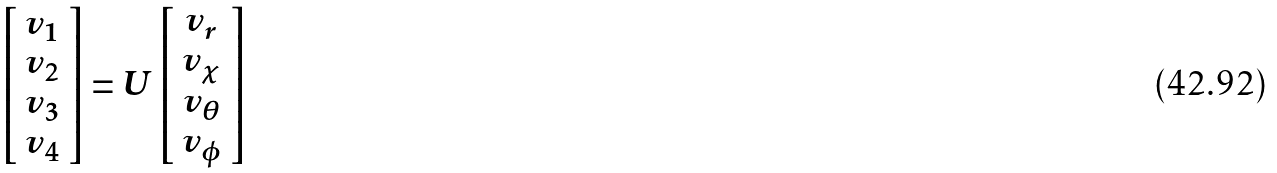<formula> <loc_0><loc_0><loc_500><loc_500>\left [ \begin{array} { c } v _ { 1 } \\ v _ { 2 } \\ v _ { 3 } \\ v _ { 4 } \end{array} \right ] = U \left [ \begin{array} { c } v _ { r } \\ v _ { \chi } \\ v _ { \theta } \\ v _ { \phi } \end{array} \right ]</formula> 